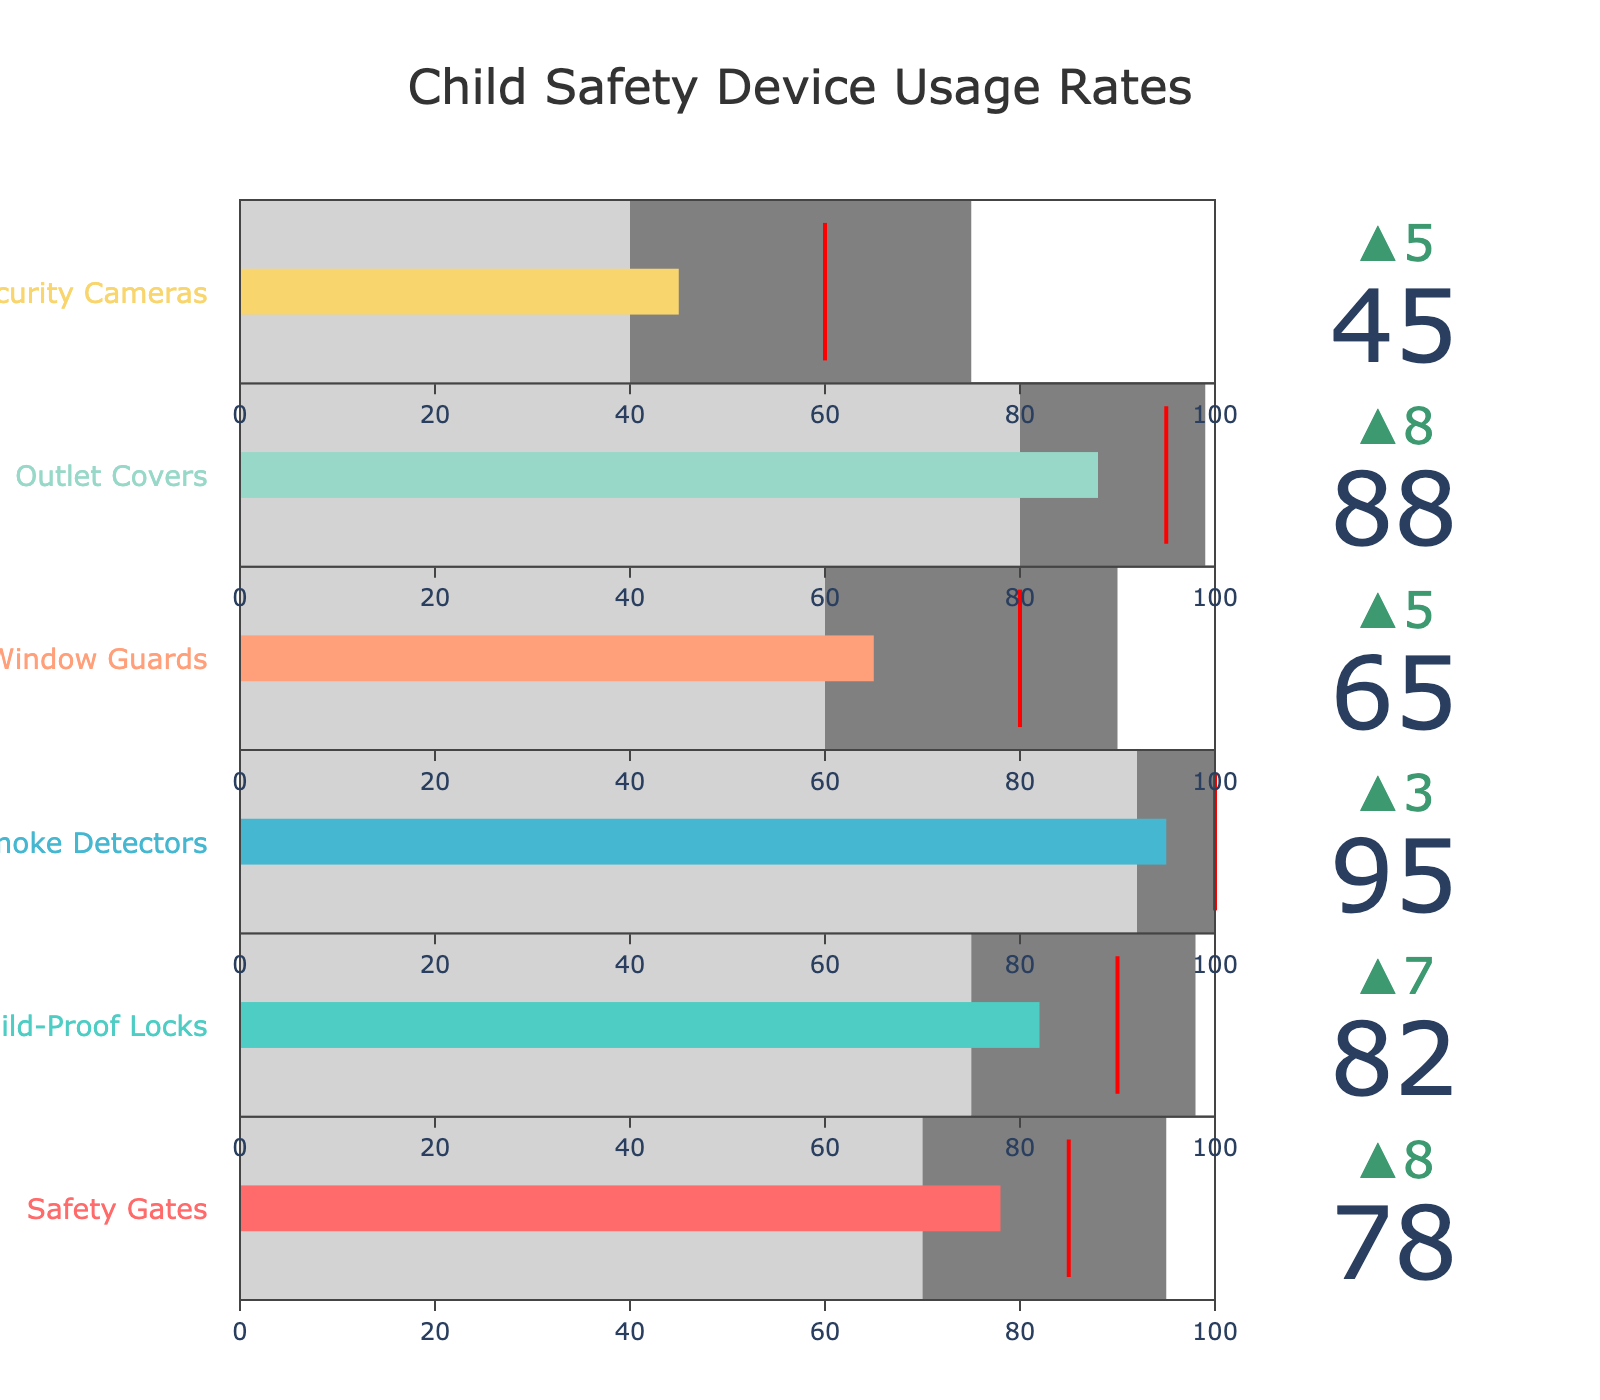What is the title of the figure? The title of the figure is usually located at the top of the plot and provides information about what is being depicted. In this case, the title is displayed prominently in a larger font size and centered.
Answer: Child Safety Device Usage Rates How many child safety devices are shown in the figure? Count the number of distinct devices listed on the y-axis (vertical axis) of the figure. Each bullet graph corresponds to one device.
Answer: 6 Which child safety device has the highest usage rate? Look at the value bars in each bullet graph. The one with the longest bar represents the highest usage rate.
Answer: Smoke Detectors How does the usage rate of Child-Proof Locks compare to its target value? Observe the position of the bar for Child-Proof Locks in relation to its target indicator, which is marked by a red line in the bullet chart.
Answer: Below Target What is the difference between the average and the best-in-class rates for Outlet Covers? Identify the average and best-in-class rates for Outlet Covers from the bullet chart. Subtract the average rate from the best-in-class rate to get the difference.
Answer: 19 Which device shows the largest delta (difference) between the usage rate and the average rate? Look at the delta indicator (arrow and number) for each device. The device with the largest delta shows the biggest difference between the usage rate and the average.
Answer: Security Cameras What percentage of households use Window Guards? Directly refer to the usage rate value presented for Window Guards.
Answer: 65% Which device's usage rate is closest to the best-in-class rate? Compare the length of the bars and see which one is nearest to the end of the darker gray area, which represents the best-in-class rate.
Answer: Smoke Detectors Is the usage rate of Security Cameras above or below the average rate for this device? Compare the usage rate bar for Security Cameras to the lighter gray area, which represents the average rate.
Answer: Above If we were to rank the devices by their usage rates, which position would Safety Gates hold? Compare the usage rate values of all devices and rank them from highest to lowest. Determine where Safety Gates stands in this ranking.
Answer: 3rd 